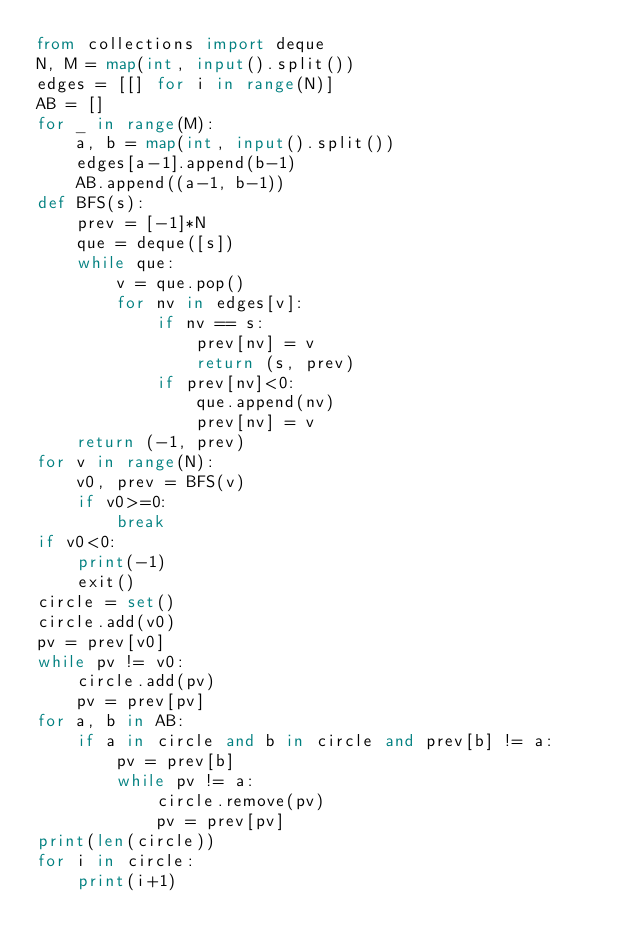<code> <loc_0><loc_0><loc_500><loc_500><_Python_>from collections import deque
N, M = map(int, input().split())
edges = [[] for i in range(N)]
AB = []
for _ in range(M):
    a, b = map(int, input().split())
    edges[a-1].append(b-1)
    AB.append((a-1, b-1))
def BFS(s):
    prev = [-1]*N
    que = deque([s])
    while que:
        v = que.pop()
        for nv in edges[v]:
            if nv == s:
                prev[nv] = v
                return (s, prev)
            if prev[nv]<0:
                que.append(nv)
                prev[nv] = v
    return (-1, prev)
for v in range(N):
    v0, prev = BFS(v)
    if v0>=0:
        break
if v0<0:
    print(-1)
    exit()
circle = set()
circle.add(v0)
pv = prev[v0]
while pv != v0:
    circle.add(pv)
    pv = prev[pv]
for a, b in AB:
    if a in circle and b in circle and prev[b] != a:
        pv = prev[b]
        while pv != a:
            circle.remove(pv)
            pv = prev[pv]
print(len(circle))
for i in circle:
    print(i+1)</code> 